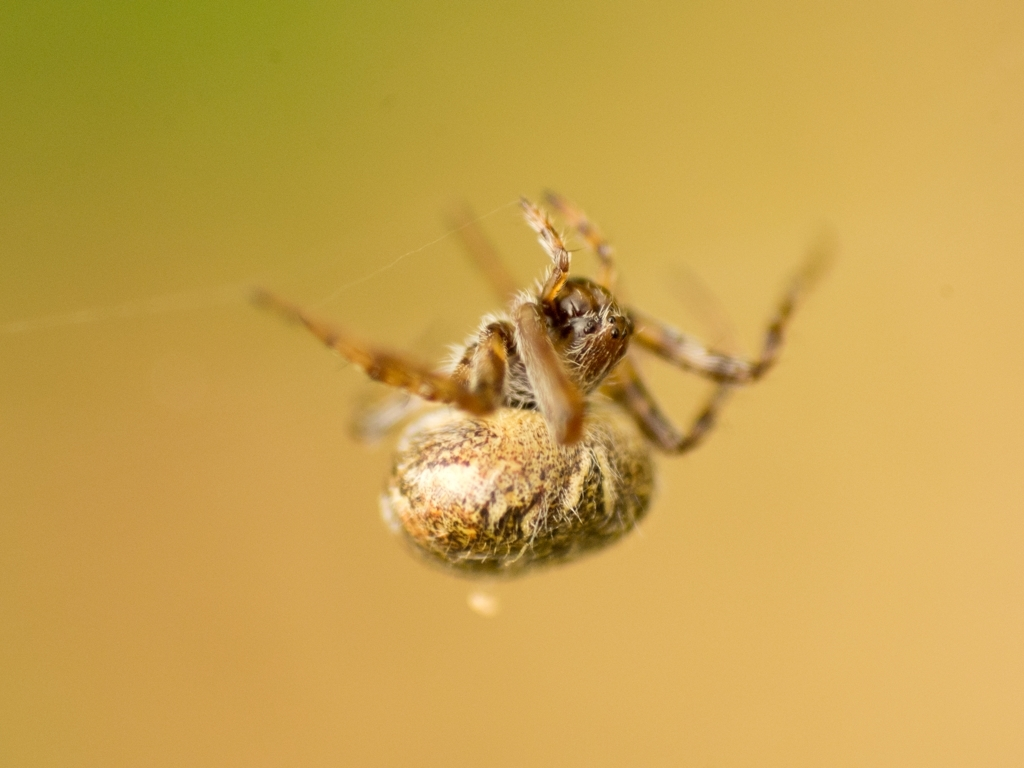What stage of life does this spider appear to be in, and what can you infer about its behavior currently? This spider seems to be an adult, given its developed abdomen and intricate web. It appears to be waiting for prey, a typical behavior where spiders remain still until vibrations in their web signal the presence of an insect. Its stance suggests readiness to pounce when the opportunity arises. 